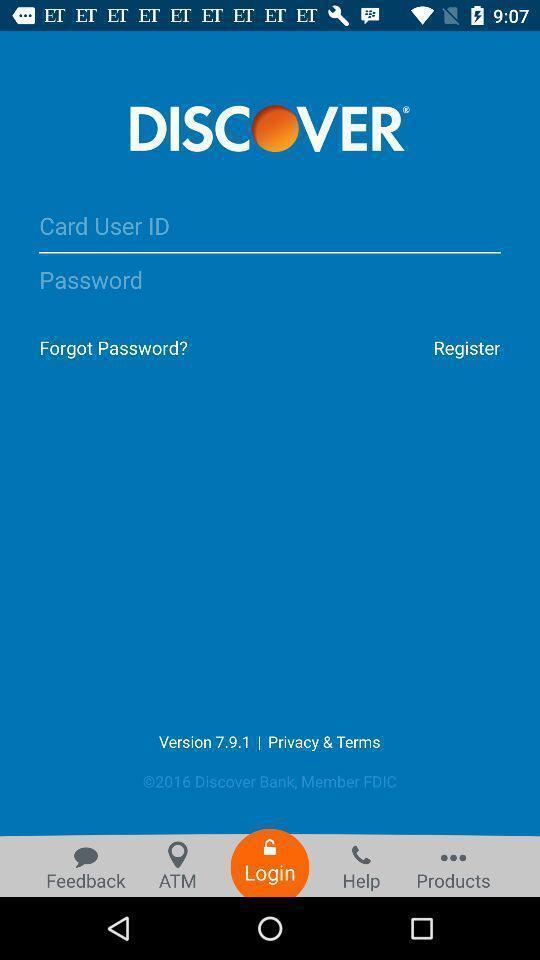Provide a textual representation of this image. Welcome page of a payment app. 